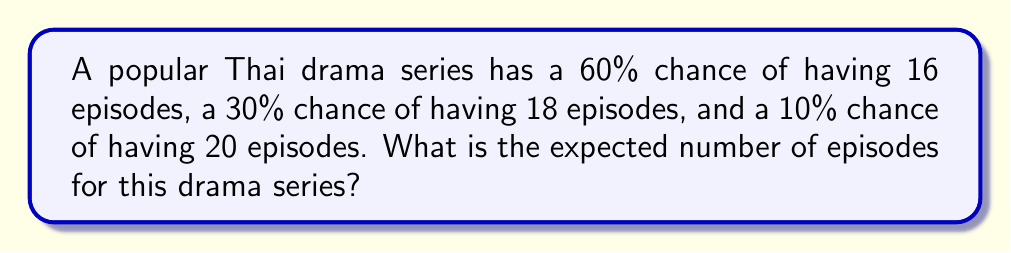Provide a solution to this math problem. To calculate the expected number of episodes, we need to use the concept of expected value. The expected value is the sum of each possible outcome multiplied by its probability.

Let's define our variables:
$E(X)$ = Expected number of episodes
$p_1 = 0.60$, $p_2 = 0.30$, $p_3 = 0.10$ (probabilities)
$x_1 = 16$, $x_2 = 18$, $x_3 = 20$ (number of episodes)

The formula for expected value is:

$$E(X) = \sum_{i=1}^{n} x_i \cdot p_i$$

Substituting our values:

$$E(X) = (16 \cdot 0.60) + (18 \cdot 0.30) + (20 \cdot 0.10)$$

Now, let's calculate each term:
1. $16 \cdot 0.60 = 9.6$
2. $18 \cdot 0.30 = 5.4$
3. $20 \cdot 0.10 = 2.0$

Adding these together:

$$E(X) = 9.6 + 5.4 + 2.0 = 17$$

Therefore, the expected number of episodes for this Thai drama series is 17.
Answer: 17 episodes 